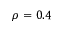Convert formula to latex. <formula><loc_0><loc_0><loc_500><loc_500>\rho = 0 . 4</formula> 